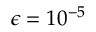Convert formula to latex. <formula><loc_0><loc_0><loc_500><loc_500>\epsilon = 1 0 ^ { - 5 }</formula> 